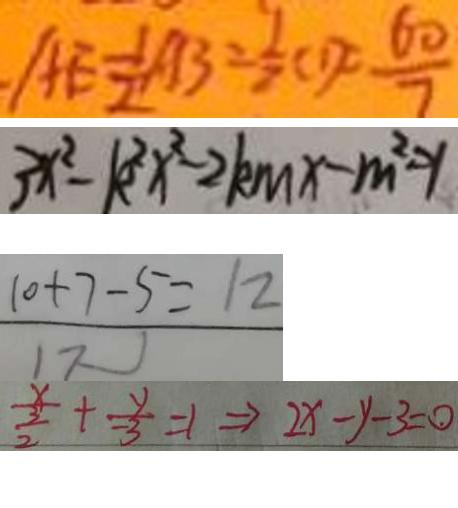<formula> <loc_0><loc_0><loc_500><loc_500>A E = \frac { 1 } { 2 } A B = \frac { 1 } { 2 } C D c = \frac { 6 0 } { 7 } 
 3 x ^ { 2 } - k ^ { 2 } x ^ { 2 } - 2 k m x - m ^ { 2 } = 1 
 \frac { 1 0 + 7 - 5 } { 1 7 } = 1 2 
 \frac { x } { \frac { 3 } { 2 } } + \frac { y } { - 3 } = 1 \Rightarrow 2 x - y - 3 = 0</formula> 